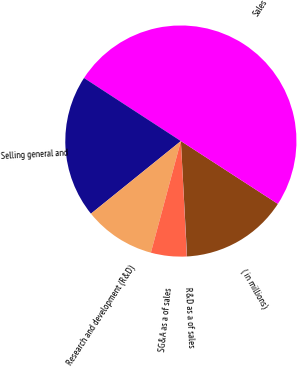Convert chart. <chart><loc_0><loc_0><loc_500><loc_500><pie_chart><fcel>( in millions)<fcel>Sales<fcel>Selling general and<fcel>Research and development (R&D)<fcel>SG&A as a of sales<fcel>R&D as a of sales<nl><fcel>15.0%<fcel>49.97%<fcel>20.0%<fcel>10.01%<fcel>5.01%<fcel>0.02%<nl></chart> 